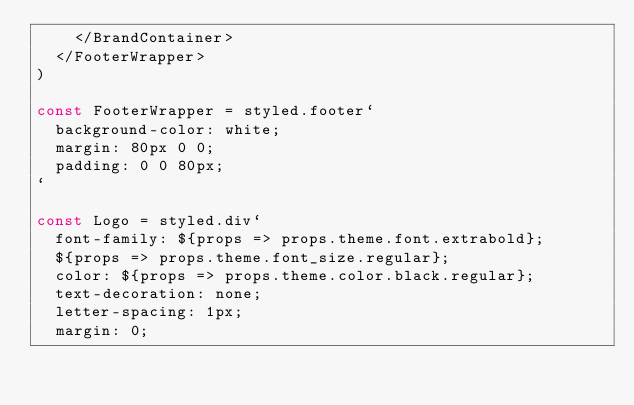Convert code to text. <code><loc_0><loc_0><loc_500><loc_500><_JavaScript_>    </BrandContainer>
  </FooterWrapper>
)

const FooterWrapper = styled.footer`
  background-color: white;
  margin: 80px 0 0;
  padding: 0 0 80px;
`

const Logo = styled.div`
  font-family: ${props => props.theme.font.extrabold};
  ${props => props.theme.font_size.regular};
  color: ${props => props.theme.color.black.regular};
  text-decoration: none;
  letter-spacing: 1px;
  margin: 0;</code> 